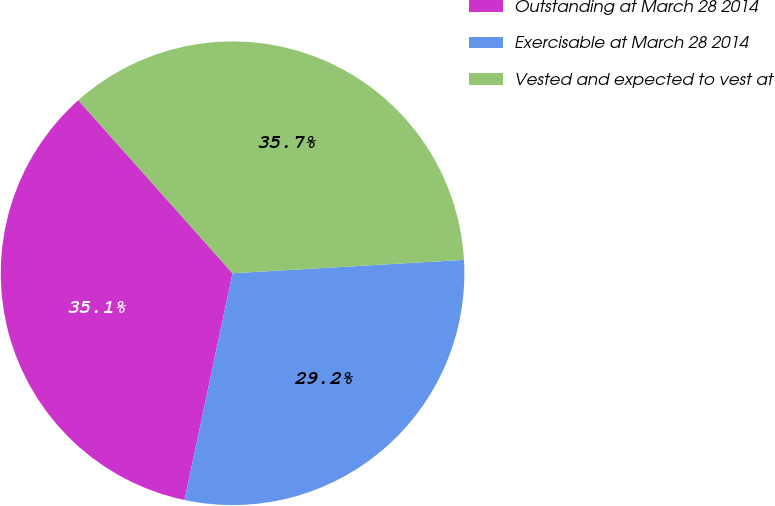Convert chart to OTSL. <chart><loc_0><loc_0><loc_500><loc_500><pie_chart><fcel>Outstanding at March 28 2014<fcel>Exercisable at March 28 2014<fcel>Vested and expected to vest at<nl><fcel>35.09%<fcel>29.24%<fcel>35.67%<nl></chart> 